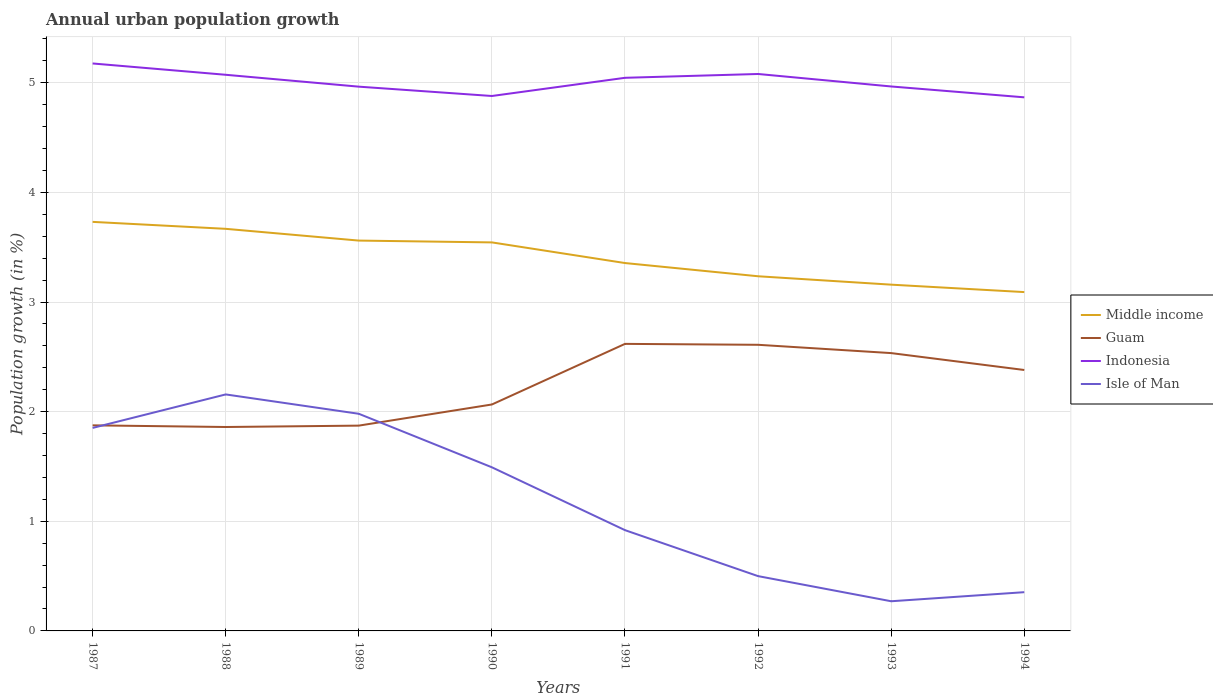Is the number of lines equal to the number of legend labels?
Your answer should be very brief. Yes. Across all years, what is the maximum percentage of urban population growth in Indonesia?
Offer a terse response. 4.87. What is the total percentage of urban population growth in Middle income in the graph?
Make the answer very short. 0.5. What is the difference between the highest and the second highest percentage of urban population growth in Middle income?
Keep it short and to the point. 0.64. What is the difference between the highest and the lowest percentage of urban population growth in Middle income?
Give a very brief answer. 4. Is the percentage of urban population growth in Indonesia strictly greater than the percentage of urban population growth in Isle of Man over the years?
Your answer should be compact. No. How many lines are there?
Provide a succinct answer. 4. What is the difference between two consecutive major ticks on the Y-axis?
Provide a short and direct response. 1. Are the values on the major ticks of Y-axis written in scientific E-notation?
Give a very brief answer. No. Does the graph contain any zero values?
Offer a terse response. No. Where does the legend appear in the graph?
Offer a terse response. Center right. What is the title of the graph?
Make the answer very short. Annual urban population growth. What is the label or title of the X-axis?
Your answer should be compact. Years. What is the label or title of the Y-axis?
Your answer should be very brief. Population growth (in %). What is the Population growth (in %) in Middle income in 1987?
Offer a terse response. 3.73. What is the Population growth (in %) of Guam in 1987?
Provide a short and direct response. 1.88. What is the Population growth (in %) in Indonesia in 1987?
Make the answer very short. 5.18. What is the Population growth (in %) in Isle of Man in 1987?
Your answer should be very brief. 1.85. What is the Population growth (in %) in Middle income in 1988?
Ensure brevity in your answer.  3.67. What is the Population growth (in %) in Guam in 1988?
Your answer should be very brief. 1.86. What is the Population growth (in %) in Indonesia in 1988?
Provide a short and direct response. 5.07. What is the Population growth (in %) of Isle of Man in 1988?
Give a very brief answer. 2.16. What is the Population growth (in %) in Middle income in 1989?
Give a very brief answer. 3.56. What is the Population growth (in %) of Guam in 1989?
Give a very brief answer. 1.87. What is the Population growth (in %) in Indonesia in 1989?
Make the answer very short. 4.96. What is the Population growth (in %) of Isle of Man in 1989?
Offer a terse response. 1.98. What is the Population growth (in %) of Middle income in 1990?
Keep it short and to the point. 3.54. What is the Population growth (in %) of Guam in 1990?
Offer a terse response. 2.07. What is the Population growth (in %) of Indonesia in 1990?
Make the answer very short. 4.88. What is the Population growth (in %) of Isle of Man in 1990?
Make the answer very short. 1.49. What is the Population growth (in %) in Middle income in 1991?
Make the answer very short. 3.36. What is the Population growth (in %) in Guam in 1991?
Your response must be concise. 2.62. What is the Population growth (in %) in Indonesia in 1991?
Your response must be concise. 5.05. What is the Population growth (in %) in Isle of Man in 1991?
Your response must be concise. 0.92. What is the Population growth (in %) of Middle income in 1992?
Your answer should be very brief. 3.24. What is the Population growth (in %) of Guam in 1992?
Give a very brief answer. 2.61. What is the Population growth (in %) in Indonesia in 1992?
Offer a very short reply. 5.08. What is the Population growth (in %) in Isle of Man in 1992?
Provide a succinct answer. 0.5. What is the Population growth (in %) of Middle income in 1993?
Give a very brief answer. 3.16. What is the Population growth (in %) in Guam in 1993?
Keep it short and to the point. 2.53. What is the Population growth (in %) of Indonesia in 1993?
Make the answer very short. 4.97. What is the Population growth (in %) of Isle of Man in 1993?
Ensure brevity in your answer.  0.27. What is the Population growth (in %) of Middle income in 1994?
Your answer should be compact. 3.09. What is the Population growth (in %) in Guam in 1994?
Your answer should be very brief. 2.38. What is the Population growth (in %) in Indonesia in 1994?
Ensure brevity in your answer.  4.87. What is the Population growth (in %) of Isle of Man in 1994?
Give a very brief answer. 0.35. Across all years, what is the maximum Population growth (in %) in Middle income?
Provide a succinct answer. 3.73. Across all years, what is the maximum Population growth (in %) of Guam?
Offer a very short reply. 2.62. Across all years, what is the maximum Population growth (in %) of Indonesia?
Offer a very short reply. 5.18. Across all years, what is the maximum Population growth (in %) in Isle of Man?
Offer a terse response. 2.16. Across all years, what is the minimum Population growth (in %) of Middle income?
Your response must be concise. 3.09. Across all years, what is the minimum Population growth (in %) of Guam?
Ensure brevity in your answer.  1.86. Across all years, what is the minimum Population growth (in %) of Indonesia?
Make the answer very short. 4.87. Across all years, what is the minimum Population growth (in %) of Isle of Man?
Make the answer very short. 0.27. What is the total Population growth (in %) in Middle income in the graph?
Give a very brief answer. 27.34. What is the total Population growth (in %) in Guam in the graph?
Ensure brevity in your answer.  17.82. What is the total Population growth (in %) in Indonesia in the graph?
Provide a succinct answer. 40.05. What is the total Population growth (in %) in Isle of Man in the graph?
Keep it short and to the point. 9.53. What is the difference between the Population growth (in %) in Middle income in 1987 and that in 1988?
Provide a short and direct response. 0.06. What is the difference between the Population growth (in %) in Guam in 1987 and that in 1988?
Offer a very short reply. 0.02. What is the difference between the Population growth (in %) of Indonesia in 1987 and that in 1988?
Keep it short and to the point. 0.1. What is the difference between the Population growth (in %) of Isle of Man in 1987 and that in 1988?
Your answer should be compact. -0.31. What is the difference between the Population growth (in %) of Middle income in 1987 and that in 1989?
Your answer should be compact. 0.17. What is the difference between the Population growth (in %) in Guam in 1987 and that in 1989?
Provide a short and direct response. 0. What is the difference between the Population growth (in %) of Indonesia in 1987 and that in 1989?
Your answer should be compact. 0.21. What is the difference between the Population growth (in %) in Isle of Man in 1987 and that in 1989?
Your answer should be compact. -0.13. What is the difference between the Population growth (in %) of Middle income in 1987 and that in 1990?
Ensure brevity in your answer.  0.19. What is the difference between the Population growth (in %) in Guam in 1987 and that in 1990?
Your answer should be very brief. -0.19. What is the difference between the Population growth (in %) in Indonesia in 1987 and that in 1990?
Make the answer very short. 0.3. What is the difference between the Population growth (in %) in Isle of Man in 1987 and that in 1990?
Offer a terse response. 0.36. What is the difference between the Population growth (in %) of Middle income in 1987 and that in 1991?
Your response must be concise. 0.38. What is the difference between the Population growth (in %) in Guam in 1987 and that in 1991?
Give a very brief answer. -0.74. What is the difference between the Population growth (in %) in Indonesia in 1987 and that in 1991?
Your response must be concise. 0.13. What is the difference between the Population growth (in %) in Isle of Man in 1987 and that in 1991?
Your response must be concise. 0.93. What is the difference between the Population growth (in %) of Middle income in 1987 and that in 1992?
Offer a very short reply. 0.5. What is the difference between the Population growth (in %) of Guam in 1987 and that in 1992?
Keep it short and to the point. -0.73. What is the difference between the Population growth (in %) in Indonesia in 1987 and that in 1992?
Give a very brief answer. 0.1. What is the difference between the Population growth (in %) of Isle of Man in 1987 and that in 1992?
Offer a very short reply. 1.35. What is the difference between the Population growth (in %) in Middle income in 1987 and that in 1993?
Offer a very short reply. 0.57. What is the difference between the Population growth (in %) in Guam in 1987 and that in 1993?
Provide a succinct answer. -0.66. What is the difference between the Population growth (in %) in Indonesia in 1987 and that in 1993?
Your answer should be compact. 0.21. What is the difference between the Population growth (in %) of Isle of Man in 1987 and that in 1993?
Make the answer very short. 1.58. What is the difference between the Population growth (in %) of Middle income in 1987 and that in 1994?
Offer a terse response. 0.64. What is the difference between the Population growth (in %) in Guam in 1987 and that in 1994?
Your answer should be very brief. -0.5. What is the difference between the Population growth (in %) of Indonesia in 1987 and that in 1994?
Offer a very short reply. 0.31. What is the difference between the Population growth (in %) of Isle of Man in 1987 and that in 1994?
Ensure brevity in your answer.  1.5. What is the difference between the Population growth (in %) of Middle income in 1988 and that in 1989?
Keep it short and to the point. 0.11. What is the difference between the Population growth (in %) of Guam in 1988 and that in 1989?
Make the answer very short. -0.01. What is the difference between the Population growth (in %) of Indonesia in 1988 and that in 1989?
Your answer should be compact. 0.11. What is the difference between the Population growth (in %) in Isle of Man in 1988 and that in 1989?
Offer a very short reply. 0.18. What is the difference between the Population growth (in %) of Middle income in 1988 and that in 1990?
Provide a short and direct response. 0.12. What is the difference between the Population growth (in %) in Guam in 1988 and that in 1990?
Give a very brief answer. -0.21. What is the difference between the Population growth (in %) in Indonesia in 1988 and that in 1990?
Offer a terse response. 0.19. What is the difference between the Population growth (in %) in Isle of Man in 1988 and that in 1990?
Make the answer very short. 0.66. What is the difference between the Population growth (in %) of Middle income in 1988 and that in 1991?
Your response must be concise. 0.31. What is the difference between the Population growth (in %) in Guam in 1988 and that in 1991?
Your response must be concise. -0.76. What is the difference between the Population growth (in %) in Indonesia in 1988 and that in 1991?
Give a very brief answer. 0.03. What is the difference between the Population growth (in %) in Isle of Man in 1988 and that in 1991?
Give a very brief answer. 1.24. What is the difference between the Population growth (in %) of Middle income in 1988 and that in 1992?
Your response must be concise. 0.43. What is the difference between the Population growth (in %) in Guam in 1988 and that in 1992?
Keep it short and to the point. -0.75. What is the difference between the Population growth (in %) in Indonesia in 1988 and that in 1992?
Provide a succinct answer. -0.01. What is the difference between the Population growth (in %) in Isle of Man in 1988 and that in 1992?
Make the answer very short. 1.66. What is the difference between the Population growth (in %) in Middle income in 1988 and that in 1993?
Offer a very short reply. 0.51. What is the difference between the Population growth (in %) in Guam in 1988 and that in 1993?
Offer a terse response. -0.67. What is the difference between the Population growth (in %) in Indonesia in 1988 and that in 1993?
Your answer should be very brief. 0.11. What is the difference between the Population growth (in %) of Isle of Man in 1988 and that in 1993?
Offer a terse response. 1.89. What is the difference between the Population growth (in %) of Middle income in 1988 and that in 1994?
Ensure brevity in your answer.  0.58. What is the difference between the Population growth (in %) of Guam in 1988 and that in 1994?
Provide a succinct answer. -0.52. What is the difference between the Population growth (in %) in Indonesia in 1988 and that in 1994?
Your answer should be very brief. 0.21. What is the difference between the Population growth (in %) of Isle of Man in 1988 and that in 1994?
Provide a short and direct response. 1.8. What is the difference between the Population growth (in %) of Middle income in 1989 and that in 1990?
Your response must be concise. 0.02. What is the difference between the Population growth (in %) in Guam in 1989 and that in 1990?
Ensure brevity in your answer.  -0.19. What is the difference between the Population growth (in %) of Indonesia in 1989 and that in 1990?
Offer a very short reply. 0.09. What is the difference between the Population growth (in %) of Isle of Man in 1989 and that in 1990?
Provide a succinct answer. 0.49. What is the difference between the Population growth (in %) in Middle income in 1989 and that in 1991?
Your answer should be compact. 0.2. What is the difference between the Population growth (in %) in Guam in 1989 and that in 1991?
Provide a short and direct response. -0.75. What is the difference between the Population growth (in %) in Indonesia in 1989 and that in 1991?
Your answer should be very brief. -0.08. What is the difference between the Population growth (in %) in Isle of Man in 1989 and that in 1991?
Your answer should be very brief. 1.06. What is the difference between the Population growth (in %) in Middle income in 1989 and that in 1992?
Your answer should be very brief. 0.33. What is the difference between the Population growth (in %) of Guam in 1989 and that in 1992?
Make the answer very short. -0.74. What is the difference between the Population growth (in %) in Indonesia in 1989 and that in 1992?
Keep it short and to the point. -0.12. What is the difference between the Population growth (in %) in Isle of Man in 1989 and that in 1992?
Ensure brevity in your answer.  1.48. What is the difference between the Population growth (in %) of Middle income in 1989 and that in 1993?
Offer a terse response. 0.4. What is the difference between the Population growth (in %) in Guam in 1989 and that in 1993?
Offer a very short reply. -0.66. What is the difference between the Population growth (in %) of Indonesia in 1989 and that in 1993?
Provide a succinct answer. -0. What is the difference between the Population growth (in %) of Isle of Man in 1989 and that in 1993?
Give a very brief answer. 1.71. What is the difference between the Population growth (in %) of Middle income in 1989 and that in 1994?
Your response must be concise. 0.47. What is the difference between the Population growth (in %) in Guam in 1989 and that in 1994?
Your answer should be compact. -0.51. What is the difference between the Population growth (in %) in Indonesia in 1989 and that in 1994?
Offer a very short reply. 0.1. What is the difference between the Population growth (in %) in Isle of Man in 1989 and that in 1994?
Ensure brevity in your answer.  1.63. What is the difference between the Population growth (in %) of Middle income in 1990 and that in 1991?
Keep it short and to the point. 0.19. What is the difference between the Population growth (in %) in Guam in 1990 and that in 1991?
Provide a succinct answer. -0.55. What is the difference between the Population growth (in %) in Indonesia in 1990 and that in 1991?
Provide a succinct answer. -0.17. What is the difference between the Population growth (in %) in Isle of Man in 1990 and that in 1991?
Your answer should be very brief. 0.57. What is the difference between the Population growth (in %) of Middle income in 1990 and that in 1992?
Give a very brief answer. 0.31. What is the difference between the Population growth (in %) in Guam in 1990 and that in 1992?
Provide a short and direct response. -0.54. What is the difference between the Population growth (in %) of Indonesia in 1990 and that in 1992?
Provide a succinct answer. -0.2. What is the difference between the Population growth (in %) of Middle income in 1990 and that in 1993?
Offer a very short reply. 0.39. What is the difference between the Population growth (in %) in Guam in 1990 and that in 1993?
Ensure brevity in your answer.  -0.47. What is the difference between the Population growth (in %) of Indonesia in 1990 and that in 1993?
Offer a terse response. -0.09. What is the difference between the Population growth (in %) of Isle of Man in 1990 and that in 1993?
Your answer should be compact. 1.22. What is the difference between the Population growth (in %) of Middle income in 1990 and that in 1994?
Offer a terse response. 0.45. What is the difference between the Population growth (in %) in Guam in 1990 and that in 1994?
Make the answer very short. -0.31. What is the difference between the Population growth (in %) of Indonesia in 1990 and that in 1994?
Your response must be concise. 0.01. What is the difference between the Population growth (in %) of Isle of Man in 1990 and that in 1994?
Offer a very short reply. 1.14. What is the difference between the Population growth (in %) of Middle income in 1991 and that in 1992?
Offer a terse response. 0.12. What is the difference between the Population growth (in %) of Guam in 1991 and that in 1992?
Keep it short and to the point. 0.01. What is the difference between the Population growth (in %) of Indonesia in 1991 and that in 1992?
Keep it short and to the point. -0.03. What is the difference between the Population growth (in %) in Isle of Man in 1991 and that in 1992?
Ensure brevity in your answer.  0.42. What is the difference between the Population growth (in %) of Middle income in 1991 and that in 1993?
Your response must be concise. 0.2. What is the difference between the Population growth (in %) in Guam in 1991 and that in 1993?
Your answer should be compact. 0.08. What is the difference between the Population growth (in %) of Indonesia in 1991 and that in 1993?
Offer a very short reply. 0.08. What is the difference between the Population growth (in %) in Isle of Man in 1991 and that in 1993?
Provide a succinct answer. 0.65. What is the difference between the Population growth (in %) of Middle income in 1991 and that in 1994?
Make the answer very short. 0.26. What is the difference between the Population growth (in %) of Guam in 1991 and that in 1994?
Offer a very short reply. 0.24. What is the difference between the Population growth (in %) in Indonesia in 1991 and that in 1994?
Your answer should be very brief. 0.18. What is the difference between the Population growth (in %) of Isle of Man in 1991 and that in 1994?
Your response must be concise. 0.57. What is the difference between the Population growth (in %) of Middle income in 1992 and that in 1993?
Your answer should be compact. 0.08. What is the difference between the Population growth (in %) of Guam in 1992 and that in 1993?
Make the answer very short. 0.08. What is the difference between the Population growth (in %) of Indonesia in 1992 and that in 1993?
Provide a succinct answer. 0.11. What is the difference between the Population growth (in %) in Isle of Man in 1992 and that in 1993?
Your response must be concise. 0.23. What is the difference between the Population growth (in %) in Middle income in 1992 and that in 1994?
Give a very brief answer. 0.14. What is the difference between the Population growth (in %) in Guam in 1992 and that in 1994?
Your answer should be compact. 0.23. What is the difference between the Population growth (in %) in Indonesia in 1992 and that in 1994?
Ensure brevity in your answer.  0.21. What is the difference between the Population growth (in %) in Isle of Man in 1992 and that in 1994?
Your response must be concise. 0.15. What is the difference between the Population growth (in %) in Middle income in 1993 and that in 1994?
Ensure brevity in your answer.  0.07. What is the difference between the Population growth (in %) in Guam in 1993 and that in 1994?
Keep it short and to the point. 0.15. What is the difference between the Population growth (in %) in Indonesia in 1993 and that in 1994?
Your answer should be compact. 0.1. What is the difference between the Population growth (in %) in Isle of Man in 1993 and that in 1994?
Offer a terse response. -0.08. What is the difference between the Population growth (in %) in Middle income in 1987 and the Population growth (in %) in Guam in 1988?
Offer a terse response. 1.87. What is the difference between the Population growth (in %) of Middle income in 1987 and the Population growth (in %) of Indonesia in 1988?
Keep it short and to the point. -1.34. What is the difference between the Population growth (in %) of Middle income in 1987 and the Population growth (in %) of Isle of Man in 1988?
Give a very brief answer. 1.57. What is the difference between the Population growth (in %) in Guam in 1987 and the Population growth (in %) in Indonesia in 1988?
Give a very brief answer. -3.2. What is the difference between the Population growth (in %) in Guam in 1987 and the Population growth (in %) in Isle of Man in 1988?
Give a very brief answer. -0.28. What is the difference between the Population growth (in %) of Indonesia in 1987 and the Population growth (in %) of Isle of Man in 1988?
Your answer should be very brief. 3.02. What is the difference between the Population growth (in %) in Middle income in 1987 and the Population growth (in %) in Guam in 1989?
Ensure brevity in your answer.  1.86. What is the difference between the Population growth (in %) in Middle income in 1987 and the Population growth (in %) in Indonesia in 1989?
Give a very brief answer. -1.23. What is the difference between the Population growth (in %) in Middle income in 1987 and the Population growth (in %) in Isle of Man in 1989?
Offer a very short reply. 1.75. What is the difference between the Population growth (in %) of Guam in 1987 and the Population growth (in %) of Indonesia in 1989?
Ensure brevity in your answer.  -3.09. What is the difference between the Population growth (in %) in Guam in 1987 and the Population growth (in %) in Isle of Man in 1989?
Keep it short and to the point. -0.11. What is the difference between the Population growth (in %) in Indonesia in 1987 and the Population growth (in %) in Isle of Man in 1989?
Provide a short and direct response. 3.2. What is the difference between the Population growth (in %) of Middle income in 1987 and the Population growth (in %) of Guam in 1990?
Keep it short and to the point. 1.67. What is the difference between the Population growth (in %) in Middle income in 1987 and the Population growth (in %) in Indonesia in 1990?
Your answer should be very brief. -1.15. What is the difference between the Population growth (in %) in Middle income in 1987 and the Population growth (in %) in Isle of Man in 1990?
Give a very brief answer. 2.24. What is the difference between the Population growth (in %) in Guam in 1987 and the Population growth (in %) in Indonesia in 1990?
Ensure brevity in your answer.  -3. What is the difference between the Population growth (in %) in Guam in 1987 and the Population growth (in %) in Isle of Man in 1990?
Your answer should be very brief. 0.38. What is the difference between the Population growth (in %) in Indonesia in 1987 and the Population growth (in %) in Isle of Man in 1990?
Your answer should be very brief. 3.68. What is the difference between the Population growth (in %) in Middle income in 1987 and the Population growth (in %) in Guam in 1991?
Your answer should be compact. 1.11. What is the difference between the Population growth (in %) of Middle income in 1987 and the Population growth (in %) of Indonesia in 1991?
Give a very brief answer. -1.31. What is the difference between the Population growth (in %) in Middle income in 1987 and the Population growth (in %) in Isle of Man in 1991?
Your answer should be compact. 2.81. What is the difference between the Population growth (in %) in Guam in 1987 and the Population growth (in %) in Indonesia in 1991?
Give a very brief answer. -3.17. What is the difference between the Population growth (in %) of Guam in 1987 and the Population growth (in %) of Isle of Man in 1991?
Provide a short and direct response. 0.96. What is the difference between the Population growth (in %) of Indonesia in 1987 and the Population growth (in %) of Isle of Man in 1991?
Keep it short and to the point. 4.26. What is the difference between the Population growth (in %) of Middle income in 1987 and the Population growth (in %) of Guam in 1992?
Make the answer very short. 1.12. What is the difference between the Population growth (in %) in Middle income in 1987 and the Population growth (in %) in Indonesia in 1992?
Keep it short and to the point. -1.35. What is the difference between the Population growth (in %) in Middle income in 1987 and the Population growth (in %) in Isle of Man in 1992?
Offer a terse response. 3.23. What is the difference between the Population growth (in %) in Guam in 1987 and the Population growth (in %) in Indonesia in 1992?
Ensure brevity in your answer.  -3.21. What is the difference between the Population growth (in %) in Guam in 1987 and the Population growth (in %) in Isle of Man in 1992?
Keep it short and to the point. 1.38. What is the difference between the Population growth (in %) in Indonesia in 1987 and the Population growth (in %) in Isle of Man in 1992?
Your response must be concise. 4.68. What is the difference between the Population growth (in %) of Middle income in 1987 and the Population growth (in %) of Guam in 1993?
Your answer should be compact. 1.2. What is the difference between the Population growth (in %) in Middle income in 1987 and the Population growth (in %) in Indonesia in 1993?
Offer a terse response. -1.24. What is the difference between the Population growth (in %) of Middle income in 1987 and the Population growth (in %) of Isle of Man in 1993?
Your answer should be very brief. 3.46. What is the difference between the Population growth (in %) in Guam in 1987 and the Population growth (in %) in Indonesia in 1993?
Offer a very short reply. -3.09. What is the difference between the Population growth (in %) in Guam in 1987 and the Population growth (in %) in Isle of Man in 1993?
Your answer should be very brief. 1.6. What is the difference between the Population growth (in %) in Indonesia in 1987 and the Population growth (in %) in Isle of Man in 1993?
Make the answer very short. 4.91. What is the difference between the Population growth (in %) in Middle income in 1987 and the Population growth (in %) in Guam in 1994?
Provide a succinct answer. 1.35. What is the difference between the Population growth (in %) in Middle income in 1987 and the Population growth (in %) in Indonesia in 1994?
Provide a succinct answer. -1.14. What is the difference between the Population growth (in %) in Middle income in 1987 and the Population growth (in %) in Isle of Man in 1994?
Ensure brevity in your answer.  3.38. What is the difference between the Population growth (in %) in Guam in 1987 and the Population growth (in %) in Indonesia in 1994?
Offer a very short reply. -2.99. What is the difference between the Population growth (in %) in Guam in 1987 and the Population growth (in %) in Isle of Man in 1994?
Your response must be concise. 1.52. What is the difference between the Population growth (in %) in Indonesia in 1987 and the Population growth (in %) in Isle of Man in 1994?
Your response must be concise. 4.82. What is the difference between the Population growth (in %) in Middle income in 1988 and the Population growth (in %) in Guam in 1989?
Provide a short and direct response. 1.8. What is the difference between the Population growth (in %) in Middle income in 1988 and the Population growth (in %) in Indonesia in 1989?
Offer a terse response. -1.3. What is the difference between the Population growth (in %) in Middle income in 1988 and the Population growth (in %) in Isle of Man in 1989?
Keep it short and to the point. 1.69. What is the difference between the Population growth (in %) in Guam in 1988 and the Population growth (in %) in Indonesia in 1989?
Provide a short and direct response. -3.1. What is the difference between the Population growth (in %) of Guam in 1988 and the Population growth (in %) of Isle of Man in 1989?
Provide a succinct answer. -0.12. What is the difference between the Population growth (in %) of Indonesia in 1988 and the Population growth (in %) of Isle of Man in 1989?
Provide a succinct answer. 3.09. What is the difference between the Population growth (in %) in Middle income in 1988 and the Population growth (in %) in Guam in 1990?
Keep it short and to the point. 1.6. What is the difference between the Population growth (in %) of Middle income in 1988 and the Population growth (in %) of Indonesia in 1990?
Keep it short and to the point. -1.21. What is the difference between the Population growth (in %) of Middle income in 1988 and the Population growth (in %) of Isle of Man in 1990?
Keep it short and to the point. 2.18. What is the difference between the Population growth (in %) of Guam in 1988 and the Population growth (in %) of Indonesia in 1990?
Provide a short and direct response. -3.02. What is the difference between the Population growth (in %) in Guam in 1988 and the Population growth (in %) in Isle of Man in 1990?
Your response must be concise. 0.37. What is the difference between the Population growth (in %) of Indonesia in 1988 and the Population growth (in %) of Isle of Man in 1990?
Make the answer very short. 3.58. What is the difference between the Population growth (in %) of Middle income in 1988 and the Population growth (in %) of Guam in 1991?
Keep it short and to the point. 1.05. What is the difference between the Population growth (in %) of Middle income in 1988 and the Population growth (in %) of Indonesia in 1991?
Ensure brevity in your answer.  -1.38. What is the difference between the Population growth (in %) of Middle income in 1988 and the Population growth (in %) of Isle of Man in 1991?
Make the answer very short. 2.75. What is the difference between the Population growth (in %) of Guam in 1988 and the Population growth (in %) of Indonesia in 1991?
Your answer should be compact. -3.19. What is the difference between the Population growth (in %) of Guam in 1988 and the Population growth (in %) of Isle of Man in 1991?
Give a very brief answer. 0.94. What is the difference between the Population growth (in %) in Indonesia in 1988 and the Population growth (in %) in Isle of Man in 1991?
Your response must be concise. 4.15. What is the difference between the Population growth (in %) in Middle income in 1988 and the Population growth (in %) in Guam in 1992?
Keep it short and to the point. 1.06. What is the difference between the Population growth (in %) in Middle income in 1988 and the Population growth (in %) in Indonesia in 1992?
Your answer should be compact. -1.41. What is the difference between the Population growth (in %) in Middle income in 1988 and the Population growth (in %) in Isle of Man in 1992?
Give a very brief answer. 3.17. What is the difference between the Population growth (in %) of Guam in 1988 and the Population growth (in %) of Indonesia in 1992?
Your answer should be very brief. -3.22. What is the difference between the Population growth (in %) in Guam in 1988 and the Population growth (in %) in Isle of Man in 1992?
Keep it short and to the point. 1.36. What is the difference between the Population growth (in %) of Indonesia in 1988 and the Population growth (in %) of Isle of Man in 1992?
Your answer should be very brief. 4.57. What is the difference between the Population growth (in %) in Middle income in 1988 and the Population growth (in %) in Guam in 1993?
Offer a terse response. 1.13. What is the difference between the Population growth (in %) in Middle income in 1988 and the Population growth (in %) in Indonesia in 1993?
Your answer should be very brief. -1.3. What is the difference between the Population growth (in %) in Middle income in 1988 and the Population growth (in %) in Isle of Man in 1993?
Your answer should be compact. 3.4. What is the difference between the Population growth (in %) of Guam in 1988 and the Population growth (in %) of Indonesia in 1993?
Your answer should be very brief. -3.11. What is the difference between the Population growth (in %) in Guam in 1988 and the Population growth (in %) in Isle of Man in 1993?
Offer a very short reply. 1.59. What is the difference between the Population growth (in %) in Indonesia in 1988 and the Population growth (in %) in Isle of Man in 1993?
Your answer should be compact. 4.8. What is the difference between the Population growth (in %) in Middle income in 1988 and the Population growth (in %) in Guam in 1994?
Your answer should be compact. 1.29. What is the difference between the Population growth (in %) in Middle income in 1988 and the Population growth (in %) in Indonesia in 1994?
Keep it short and to the point. -1.2. What is the difference between the Population growth (in %) in Middle income in 1988 and the Population growth (in %) in Isle of Man in 1994?
Your response must be concise. 3.31. What is the difference between the Population growth (in %) in Guam in 1988 and the Population growth (in %) in Indonesia in 1994?
Provide a short and direct response. -3.01. What is the difference between the Population growth (in %) in Guam in 1988 and the Population growth (in %) in Isle of Man in 1994?
Your answer should be very brief. 1.51. What is the difference between the Population growth (in %) in Indonesia in 1988 and the Population growth (in %) in Isle of Man in 1994?
Ensure brevity in your answer.  4.72. What is the difference between the Population growth (in %) in Middle income in 1989 and the Population growth (in %) in Guam in 1990?
Keep it short and to the point. 1.5. What is the difference between the Population growth (in %) in Middle income in 1989 and the Population growth (in %) in Indonesia in 1990?
Keep it short and to the point. -1.32. What is the difference between the Population growth (in %) in Middle income in 1989 and the Population growth (in %) in Isle of Man in 1990?
Your answer should be compact. 2.07. What is the difference between the Population growth (in %) of Guam in 1989 and the Population growth (in %) of Indonesia in 1990?
Give a very brief answer. -3.01. What is the difference between the Population growth (in %) in Guam in 1989 and the Population growth (in %) in Isle of Man in 1990?
Your response must be concise. 0.38. What is the difference between the Population growth (in %) in Indonesia in 1989 and the Population growth (in %) in Isle of Man in 1990?
Give a very brief answer. 3.47. What is the difference between the Population growth (in %) of Middle income in 1989 and the Population growth (in %) of Guam in 1991?
Offer a terse response. 0.94. What is the difference between the Population growth (in %) in Middle income in 1989 and the Population growth (in %) in Indonesia in 1991?
Your answer should be compact. -1.48. What is the difference between the Population growth (in %) in Middle income in 1989 and the Population growth (in %) in Isle of Man in 1991?
Ensure brevity in your answer.  2.64. What is the difference between the Population growth (in %) of Guam in 1989 and the Population growth (in %) of Indonesia in 1991?
Your response must be concise. -3.17. What is the difference between the Population growth (in %) in Guam in 1989 and the Population growth (in %) in Isle of Man in 1991?
Provide a succinct answer. 0.95. What is the difference between the Population growth (in %) in Indonesia in 1989 and the Population growth (in %) in Isle of Man in 1991?
Provide a succinct answer. 4.05. What is the difference between the Population growth (in %) of Middle income in 1989 and the Population growth (in %) of Guam in 1992?
Provide a succinct answer. 0.95. What is the difference between the Population growth (in %) in Middle income in 1989 and the Population growth (in %) in Indonesia in 1992?
Your response must be concise. -1.52. What is the difference between the Population growth (in %) in Middle income in 1989 and the Population growth (in %) in Isle of Man in 1992?
Make the answer very short. 3.06. What is the difference between the Population growth (in %) of Guam in 1989 and the Population growth (in %) of Indonesia in 1992?
Keep it short and to the point. -3.21. What is the difference between the Population growth (in %) in Guam in 1989 and the Population growth (in %) in Isle of Man in 1992?
Give a very brief answer. 1.37. What is the difference between the Population growth (in %) of Indonesia in 1989 and the Population growth (in %) of Isle of Man in 1992?
Provide a short and direct response. 4.46. What is the difference between the Population growth (in %) in Middle income in 1989 and the Population growth (in %) in Guam in 1993?
Your answer should be compact. 1.03. What is the difference between the Population growth (in %) in Middle income in 1989 and the Population growth (in %) in Indonesia in 1993?
Provide a succinct answer. -1.41. What is the difference between the Population growth (in %) in Middle income in 1989 and the Population growth (in %) in Isle of Man in 1993?
Make the answer very short. 3.29. What is the difference between the Population growth (in %) of Guam in 1989 and the Population growth (in %) of Indonesia in 1993?
Offer a terse response. -3.09. What is the difference between the Population growth (in %) in Guam in 1989 and the Population growth (in %) in Isle of Man in 1993?
Give a very brief answer. 1.6. What is the difference between the Population growth (in %) in Indonesia in 1989 and the Population growth (in %) in Isle of Man in 1993?
Your response must be concise. 4.69. What is the difference between the Population growth (in %) in Middle income in 1989 and the Population growth (in %) in Guam in 1994?
Provide a succinct answer. 1.18. What is the difference between the Population growth (in %) of Middle income in 1989 and the Population growth (in %) of Indonesia in 1994?
Make the answer very short. -1.31. What is the difference between the Population growth (in %) of Middle income in 1989 and the Population growth (in %) of Isle of Man in 1994?
Give a very brief answer. 3.21. What is the difference between the Population growth (in %) in Guam in 1989 and the Population growth (in %) in Indonesia in 1994?
Provide a succinct answer. -2.99. What is the difference between the Population growth (in %) in Guam in 1989 and the Population growth (in %) in Isle of Man in 1994?
Ensure brevity in your answer.  1.52. What is the difference between the Population growth (in %) in Indonesia in 1989 and the Population growth (in %) in Isle of Man in 1994?
Offer a very short reply. 4.61. What is the difference between the Population growth (in %) in Middle income in 1990 and the Population growth (in %) in Guam in 1991?
Keep it short and to the point. 0.93. What is the difference between the Population growth (in %) of Middle income in 1990 and the Population growth (in %) of Indonesia in 1991?
Offer a very short reply. -1.5. What is the difference between the Population growth (in %) of Middle income in 1990 and the Population growth (in %) of Isle of Man in 1991?
Ensure brevity in your answer.  2.62. What is the difference between the Population growth (in %) in Guam in 1990 and the Population growth (in %) in Indonesia in 1991?
Provide a short and direct response. -2.98. What is the difference between the Population growth (in %) in Guam in 1990 and the Population growth (in %) in Isle of Man in 1991?
Offer a terse response. 1.15. What is the difference between the Population growth (in %) in Indonesia in 1990 and the Population growth (in %) in Isle of Man in 1991?
Ensure brevity in your answer.  3.96. What is the difference between the Population growth (in %) of Middle income in 1990 and the Population growth (in %) of Guam in 1992?
Give a very brief answer. 0.93. What is the difference between the Population growth (in %) in Middle income in 1990 and the Population growth (in %) in Indonesia in 1992?
Your answer should be very brief. -1.54. What is the difference between the Population growth (in %) in Middle income in 1990 and the Population growth (in %) in Isle of Man in 1992?
Your response must be concise. 3.04. What is the difference between the Population growth (in %) in Guam in 1990 and the Population growth (in %) in Indonesia in 1992?
Make the answer very short. -3.01. What is the difference between the Population growth (in %) of Guam in 1990 and the Population growth (in %) of Isle of Man in 1992?
Ensure brevity in your answer.  1.57. What is the difference between the Population growth (in %) of Indonesia in 1990 and the Population growth (in %) of Isle of Man in 1992?
Provide a succinct answer. 4.38. What is the difference between the Population growth (in %) in Middle income in 1990 and the Population growth (in %) in Guam in 1993?
Your answer should be very brief. 1.01. What is the difference between the Population growth (in %) of Middle income in 1990 and the Population growth (in %) of Indonesia in 1993?
Offer a terse response. -1.42. What is the difference between the Population growth (in %) of Middle income in 1990 and the Population growth (in %) of Isle of Man in 1993?
Keep it short and to the point. 3.27. What is the difference between the Population growth (in %) of Guam in 1990 and the Population growth (in %) of Indonesia in 1993?
Your answer should be compact. -2.9. What is the difference between the Population growth (in %) of Guam in 1990 and the Population growth (in %) of Isle of Man in 1993?
Offer a terse response. 1.79. What is the difference between the Population growth (in %) of Indonesia in 1990 and the Population growth (in %) of Isle of Man in 1993?
Make the answer very short. 4.61. What is the difference between the Population growth (in %) in Middle income in 1990 and the Population growth (in %) in Guam in 1994?
Offer a very short reply. 1.16. What is the difference between the Population growth (in %) of Middle income in 1990 and the Population growth (in %) of Indonesia in 1994?
Ensure brevity in your answer.  -1.32. What is the difference between the Population growth (in %) of Middle income in 1990 and the Population growth (in %) of Isle of Man in 1994?
Your answer should be compact. 3.19. What is the difference between the Population growth (in %) of Guam in 1990 and the Population growth (in %) of Indonesia in 1994?
Keep it short and to the point. -2.8. What is the difference between the Population growth (in %) of Guam in 1990 and the Population growth (in %) of Isle of Man in 1994?
Provide a short and direct response. 1.71. What is the difference between the Population growth (in %) in Indonesia in 1990 and the Population growth (in %) in Isle of Man in 1994?
Provide a short and direct response. 4.53. What is the difference between the Population growth (in %) of Middle income in 1991 and the Population growth (in %) of Guam in 1992?
Provide a succinct answer. 0.75. What is the difference between the Population growth (in %) of Middle income in 1991 and the Population growth (in %) of Indonesia in 1992?
Offer a terse response. -1.72. What is the difference between the Population growth (in %) of Middle income in 1991 and the Population growth (in %) of Isle of Man in 1992?
Ensure brevity in your answer.  2.86. What is the difference between the Population growth (in %) in Guam in 1991 and the Population growth (in %) in Indonesia in 1992?
Offer a very short reply. -2.46. What is the difference between the Population growth (in %) in Guam in 1991 and the Population growth (in %) in Isle of Man in 1992?
Your answer should be very brief. 2.12. What is the difference between the Population growth (in %) of Indonesia in 1991 and the Population growth (in %) of Isle of Man in 1992?
Give a very brief answer. 4.55. What is the difference between the Population growth (in %) in Middle income in 1991 and the Population growth (in %) in Guam in 1993?
Your answer should be very brief. 0.82. What is the difference between the Population growth (in %) in Middle income in 1991 and the Population growth (in %) in Indonesia in 1993?
Give a very brief answer. -1.61. What is the difference between the Population growth (in %) of Middle income in 1991 and the Population growth (in %) of Isle of Man in 1993?
Make the answer very short. 3.09. What is the difference between the Population growth (in %) of Guam in 1991 and the Population growth (in %) of Indonesia in 1993?
Keep it short and to the point. -2.35. What is the difference between the Population growth (in %) of Guam in 1991 and the Population growth (in %) of Isle of Man in 1993?
Give a very brief answer. 2.35. What is the difference between the Population growth (in %) of Indonesia in 1991 and the Population growth (in %) of Isle of Man in 1993?
Make the answer very short. 4.77. What is the difference between the Population growth (in %) of Middle income in 1991 and the Population growth (in %) of Guam in 1994?
Your response must be concise. 0.98. What is the difference between the Population growth (in %) in Middle income in 1991 and the Population growth (in %) in Indonesia in 1994?
Ensure brevity in your answer.  -1.51. What is the difference between the Population growth (in %) in Middle income in 1991 and the Population growth (in %) in Isle of Man in 1994?
Offer a terse response. 3. What is the difference between the Population growth (in %) in Guam in 1991 and the Population growth (in %) in Indonesia in 1994?
Your answer should be very brief. -2.25. What is the difference between the Population growth (in %) of Guam in 1991 and the Population growth (in %) of Isle of Man in 1994?
Your response must be concise. 2.27. What is the difference between the Population growth (in %) in Indonesia in 1991 and the Population growth (in %) in Isle of Man in 1994?
Make the answer very short. 4.69. What is the difference between the Population growth (in %) of Middle income in 1992 and the Population growth (in %) of Guam in 1993?
Offer a very short reply. 0.7. What is the difference between the Population growth (in %) of Middle income in 1992 and the Population growth (in %) of Indonesia in 1993?
Provide a succinct answer. -1.73. What is the difference between the Population growth (in %) of Middle income in 1992 and the Population growth (in %) of Isle of Man in 1993?
Your response must be concise. 2.96. What is the difference between the Population growth (in %) in Guam in 1992 and the Population growth (in %) in Indonesia in 1993?
Your response must be concise. -2.36. What is the difference between the Population growth (in %) in Guam in 1992 and the Population growth (in %) in Isle of Man in 1993?
Provide a succinct answer. 2.34. What is the difference between the Population growth (in %) in Indonesia in 1992 and the Population growth (in %) in Isle of Man in 1993?
Provide a succinct answer. 4.81. What is the difference between the Population growth (in %) of Middle income in 1992 and the Population growth (in %) of Guam in 1994?
Your answer should be compact. 0.85. What is the difference between the Population growth (in %) of Middle income in 1992 and the Population growth (in %) of Indonesia in 1994?
Give a very brief answer. -1.63. What is the difference between the Population growth (in %) of Middle income in 1992 and the Population growth (in %) of Isle of Man in 1994?
Your response must be concise. 2.88. What is the difference between the Population growth (in %) in Guam in 1992 and the Population growth (in %) in Indonesia in 1994?
Offer a terse response. -2.26. What is the difference between the Population growth (in %) of Guam in 1992 and the Population growth (in %) of Isle of Man in 1994?
Offer a very short reply. 2.26. What is the difference between the Population growth (in %) in Indonesia in 1992 and the Population growth (in %) in Isle of Man in 1994?
Keep it short and to the point. 4.73. What is the difference between the Population growth (in %) in Middle income in 1993 and the Population growth (in %) in Guam in 1994?
Offer a terse response. 0.78. What is the difference between the Population growth (in %) in Middle income in 1993 and the Population growth (in %) in Indonesia in 1994?
Make the answer very short. -1.71. What is the difference between the Population growth (in %) in Middle income in 1993 and the Population growth (in %) in Isle of Man in 1994?
Provide a short and direct response. 2.81. What is the difference between the Population growth (in %) of Guam in 1993 and the Population growth (in %) of Indonesia in 1994?
Ensure brevity in your answer.  -2.33. What is the difference between the Population growth (in %) of Guam in 1993 and the Population growth (in %) of Isle of Man in 1994?
Provide a succinct answer. 2.18. What is the difference between the Population growth (in %) of Indonesia in 1993 and the Population growth (in %) of Isle of Man in 1994?
Make the answer very short. 4.61. What is the average Population growth (in %) in Middle income per year?
Your answer should be very brief. 3.42. What is the average Population growth (in %) of Guam per year?
Your answer should be very brief. 2.23. What is the average Population growth (in %) in Indonesia per year?
Your answer should be compact. 5.01. What is the average Population growth (in %) in Isle of Man per year?
Give a very brief answer. 1.19. In the year 1987, what is the difference between the Population growth (in %) in Middle income and Population growth (in %) in Guam?
Give a very brief answer. 1.86. In the year 1987, what is the difference between the Population growth (in %) of Middle income and Population growth (in %) of Indonesia?
Offer a terse response. -1.45. In the year 1987, what is the difference between the Population growth (in %) in Middle income and Population growth (in %) in Isle of Man?
Make the answer very short. 1.88. In the year 1987, what is the difference between the Population growth (in %) in Guam and Population growth (in %) in Indonesia?
Keep it short and to the point. -3.3. In the year 1987, what is the difference between the Population growth (in %) in Guam and Population growth (in %) in Isle of Man?
Offer a very short reply. 0.02. In the year 1987, what is the difference between the Population growth (in %) of Indonesia and Population growth (in %) of Isle of Man?
Keep it short and to the point. 3.32. In the year 1988, what is the difference between the Population growth (in %) in Middle income and Population growth (in %) in Guam?
Your response must be concise. 1.81. In the year 1988, what is the difference between the Population growth (in %) of Middle income and Population growth (in %) of Indonesia?
Ensure brevity in your answer.  -1.41. In the year 1988, what is the difference between the Population growth (in %) of Middle income and Population growth (in %) of Isle of Man?
Make the answer very short. 1.51. In the year 1988, what is the difference between the Population growth (in %) in Guam and Population growth (in %) in Indonesia?
Your answer should be very brief. -3.21. In the year 1988, what is the difference between the Population growth (in %) of Guam and Population growth (in %) of Isle of Man?
Offer a very short reply. -0.3. In the year 1988, what is the difference between the Population growth (in %) of Indonesia and Population growth (in %) of Isle of Man?
Give a very brief answer. 2.92. In the year 1989, what is the difference between the Population growth (in %) of Middle income and Population growth (in %) of Guam?
Offer a very short reply. 1.69. In the year 1989, what is the difference between the Population growth (in %) in Middle income and Population growth (in %) in Indonesia?
Ensure brevity in your answer.  -1.4. In the year 1989, what is the difference between the Population growth (in %) of Middle income and Population growth (in %) of Isle of Man?
Keep it short and to the point. 1.58. In the year 1989, what is the difference between the Population growth (in %) of Guam and Population growth (in %) of Indonesia?
Give a very brief answer. -3.09. In the year 1989, what is the difference between the Population growth (in %) in Guam and Population growth (in %) in Isle of Man?
Your response must be concise. -0.11. In the year 1989, what is the difference between the Population growth (in %) in Indonesia and Population growth (in %) in Isle of Man?
Provide a short and direct response. 2.98. In the year 1990, what is the difference between the Population growth (in %) of Middle income and Population growth (in %) of Guam?
Your answer should be compact. 1.48. In the year 1990, what is the difference between the Population growth (in %) of Middle income and Population growth (in %) of Indonesia?
Your answer should be very brief. -1.34. In the year 1990, what is the difference between the Population growth (in %) in Middle income and Population growth (in %) in Isle of Man?
Make the answer very short. 2.05. In the year 1990, what is the difference between the Population growth (in %) in Guam and Population growth (in %) in Indonesia?
Offer a terse response. -2.81. In the year 1990, what is the difference between the Population growth (in %) of Guam and Population growth (in %) of Isle of Man?
Offer a very short reply. 0.57. In the year 1990, what is the difference between the Population growth (in %) in Indonesia and Population growth (in %) in Isle of Man?
Your answer should be very brief. 3.39. In the year 1991, what is the difference between the Population growth (in %) in Middle income and Population growth (in %) in Guam?
Your response must be concise. 0.74. In the year 1991, what is the difference between the Population growth (in %) of Middle income and Population growth (in %) of Indonesia?
Keep it short and to the point. -1.69. In the year 1991, what is the difference between the Population growth (in %) of Middle income and Population growth (in %) of Isle of Man?
Ensure brevity in your answer.  2.44. In the year 1991, what is the difference between the Population growth (in %) of Guam and Population growth (in %) of Indonesia?
Your response must be concise. -2.43. In the year 1991, what is the difference between the Population growth (in %) in Guam and Population growth (in %) in Isle of Man?
Keep it short and to the point. 1.7. In the year 1991, what is the difference between the Population growth (in %) of Indonesia and Population growth (in %) of Isle of Man?
Offer a very short reply. 4.13. In the year 1992, what is the difference between the Population growth (in %) of Middle income and Population growth (in %) of Guam?
Keep it short and to the point. 0.63. In the year 1992, what is the difference between the Population growth (in %) in Middle income and Population growth (in %) in Indonesia?
Offer a terse response. -1.85. In the year 1992, what is the difference between the Population growth (in %) of Middle income and Population growth (in %) of Isle of Man?
Your answer should be very brief. 2.74. In the year 1992, what is the difference between the Population growth (in %) in Guam and Population growth (in %) in Indonesia?
Ensure brevity in your answer.  -2.47. In the year 1992, what is the difference between the Population growth (in %) of Guam and Population growth (in %) of Isle of Man?
Ensure brevity in your answer.  2.11. In the year 1992, what is the difference between the Population growth (in %) in Indonesia and Population growth (in %) in Isle of Man?
Make the answer very short. 4.58. In the year 1993, what is the difference between the Population growth (in %) of Middle income and Population growth (in %) of Guam?
Your answer should be compact. 0.62. In the year 1993, what is the difference between the Population growth (in %) of Middle income and Population growth (in %) of Indonesia?
Your answer should be very brief. -1.81. In the year 1993, what is the difference between the Population growth (in %) of Middle income and Population growth (in %) of Isle of Man?
Give a very brief answer. 2.89. In the year 1993, what is the difference between the Population growth (in %) of Guam and Population growth (in %) of Indonesia?
Provide a short and direct response. -2.43. In the year 1993, what is the difference between the Population growth (in %) of Guam and Population growth (in %) of Isle of Man?
Your response must be concise. 2.26. In the year 1993, what is the difference between the Population growth (in %) in Indonesia and Population growth (in %) in Isle of Man?
Provide a short and direct response. 4.7. In the year 1994, what is the difference between the Population growth (in %) in Middle income and Population growth (in %) in Guam?
Your answer should be compact. 0.71. In the year 1994, what is the difference between the Population growth (in %) in Middle income and Population growth (in %) in Indonesia?
Your response must be concise. -1.78. In the year 1994, what is the difference between the Population growth (in %) of Middle income and Population growth (in %) of Isle of Man?
Your answer should be very brief. 2.74. In the year 1994, what is the difference between the Population growth (in %) in Guam and Population growth (in %) in Indonesia?
Provide a short and direct response. -2.49. In the year 1994, what is the difference between the Population growth (in %) of Guam and Population growth (in %) of Isle of Man?
Your response must be concise. 2.03. In the year 1994, what is the difference between the Population growth (in %) in Indonesia and Population growth (in %) in Isle of Man?
Give a very brief answer. 4.51. What is the ratio of the Population growth (in %) of Middle income in 1987 to that in 1988?
Give a very brief answer. 1.02. What is the ratio of the Population growth (in %) of Guam in 1987 to that in 1988?
Give a very brief answer. 1.01. What is the ratio of the Population growth (in %) of Indonesia in 1987 to that in 1988?
Your answer should be compact. 1.02. What is the ratio of the Population growth (in %) in Isle of Man in 1987 to that in 1988?
Keep it short and to the point. 0.86. What is the ratio of the Population growth (in %) of Middle income in 1987 to that in 1989?
Ensure brevity in your answer.  1.05. What is the ratio of the Population growth (in %) of Guam in 1987 to that in 1989?
Offer a very short reply. 1. What is the ratio of the Population growth (in %) of Indonesia in 1987 to that in 1989?
Offer a terse response. 1.04. What is the ratio of the Population growth (in %) in Isle of Man in 1987 to that in 1989?
Offer a terse response. 0.93. What is the ratio of the Population growth (in %) in Middle income in 1987 to that in 1990?
Ensure brevity in your answer.  1.05. What is the ratio of the Population growth (in %) of Guam in 1987 to that in 1990?
Give a very brief answer. 0.91. What is the ratio of the Population growth (in %) in Indonesia in 1987 to that in 1990?
Give a very brief answer. 1.06. What is the ratio of the Population growth (in %) in Isle of Man in 1987 to that in 1990?
Offer a very short reply. 1.24. What is the ratio of the Population growth (in %) in Middle income in 1987 to that in 1991?
Your answer should be very brief. 1.11. What is the ratio of the Population growth (in %) of Guam in 1987 to that in 1991?
Make the answer very short. 0.72. What is the ratio of the Population growth (in %) of Indonesia in 1987 to that in 1991?
Your response must be concise. 1.03. What is the ratio of the Population growth (in %) in Isle of Man in 1987 to that in 1991?
Ensure brevity in your answer.  2.01. What is the ratio of the Population growth (in %) of Middle income in 1987 to that in 1992?
Offer a terse response. 1.15. What is the ratio of the Population growth (in %) of Guam in 1987 to that in 1992?
Your answer should be compact. 0.72. What is the ratio of the Population growth (in %) of Indonesia in 1987 to that in 1992?
Ensure brevity in your answer.  1.02. What is the ratio of the Population growth (in %) in Isle of Man in 1987 to that in 1992?
Your answer should be very brief. 3.7. What is the ratio of the Population growth (in %) of Middle income in 1987 to that in 1993?
Give a very brief answer. 1.18. What is the ratio of the Population growth (in %) in Guam in 1987 to that in 1993?
Your answer should be very brief. 0.74. What is the ratio of the Population growth (in %) of Indonesia in 1987 to that in 1993?
Make the answer very short. 1.04. What is the ratio of the Population growth (in %) of Isle of Man in 1987 to that in 1993?
Keep it short and to the point. 6.84. What is the ratio of the Population growth (in %) in Middle income in 1987 to that in 1994?
Your response must be concise. 1.21. What is the ratio of the Population growth (in %) of Guam in 1987 to that in 1994?
Provide a succinct answer. 0.79. What is the ratio of the Population growth (in %) in Indonesia in 1987 to that in 1994?
Ensure brevity in your answer.  1.06. What is the ratio of the Population growth (in %) of Isle of Man in 1987 to that in 1994?
Offer a very short reply. 5.24. What is the ratio of the Population growth (in %) in Middle income in 1988 to that in 1989?
Ensure brevity in your answer.  1.03. What is the ratio of the Population growth (in %) in Guam in 1988 to that in 1989?
Provide a short and direct response. 0.99. What is the ratio of the Population growth (in %) in Indonesia in 1988 to that in 1989?
Provide a short and direct response. 1.02. What is the ratio of the Population growth (in %) in Isle of Man in 1988 to that in 1989?
Your answer should be very brief. 1.09. What is the ratio of the Population growth (in %) in Middle income in 1988 to that in 1990?
Provide a short and direct response. 1.03. What is the ratio of the Population growth (in %) in Guam in 1988 to that in 1990?
Offer a very short reply. 0.9. What is the ratio of the Population growth (in %) in Indonesia in 1988 to that in 1990?
Keep it short and to the point. 1.04. What is the ratio of the Population growth (in %) in Isle of Man in 1988 to that in 1990?
Provide a short and direct response. 1.45. What is the ratio of the Population growth (in %) in Middle income in 1988 to that in 1991?
Provide a short and direct response. 1.09. What is the ratio of the Population growth (in %) in Guam in 1988 to that in 1991?
Ensure brevity in your answer.  0.71. What is the ratio of the Population growth (in %) in Isle of Man in 1988 to that in 1991?
Offer a very short reply. 2.35. What is the ratio of the Population growth (in %) of Middle income in 1988 to that in 1992?
Your answer should be very brief. 1.13. What is the ratio of the Population growth (in %) of Guam in 1988 to that in 1992?
Offer a very short reply. 0.71. What is the ratio of the Population growth (in %) in Indonesia in 1988 to that in 1992?
Ensure brevity in your answer.  1. What is the ratio of the Population growth (in %) in Isle of Man in 1988 to that in 1992?
Ensure brevity in your answer.  4.32. What is the ratio of the Population growth (in %) in Middle income in 1988 to that in 1993?
Make the answer very short. 1.16. What is the ratio of the Population growth (in %) of Guam in 1988 to that in 1993?
Your answer should be very brief. 0.73. What is the ratio of the Population growth (in %) in Indonesia in 1988 to that in 1993?
Offer a terse response. 1.02. What is the ratio of the Population growth (in %) in Isle of Man in 1988 to that in 1993?
Offer a very short reply. 7.97. What is the ratio of the Population growth (in %) of Middle income in 1988 to that in 1994?
Offer a very short reply. 1.19. What is the ratio of the Population growth (in %) in Guam in 1988 to that in 1994?
Your response must be concise. 0.78. What is the ratio of the Population growth (in %) in Indonesia in 1988 to that in 1994?
Provide a short and direct response. 1.04. What is the ratio of the Population growth (in %) of Isle of Man in 1988 to that in 1994?
Provide a short and direct response. 6.1. What is the ratio of the Population growth (in %) in Middle income in 1989 to that in 1990?
Keep it short and to the point. 1. What is the ratio of the Population growth (in %) in Guam in 1989 to that in 1990?
Your response must be concise. 0.91. What is the ratio of the Population growth (in %) in Indonesia in 1989 to that in 1990?
Offer a terse response. 1.02. What is the ratio of the Population growth (in %) in Isle of Man in 1989 to that in 1990?
Your answer should be compact. 1.33. What is the ratio of the Population growth (in %) in Middle income in 1989 to that in 1991?
Keep it short and to the point. 1.06. What is the ratio of the Population growth (in %) of Guam in 1989 to that in 1991?
Your response must be concise. 0.72. What is the ratio of the Population growth (in %) of Indonesia in 1989 to that in 1991?
Offer a very short reply. 0.98. What is the ratio of the Population growth (in %) in Isle of Man in 1989 to that in 1991?
Provide a succinct answer. 2.15. What is the ratio of the Population growth (in %) of Middle income in 1989 to that in 1992?
Provide a short and direct response. 1.1. What is the ratio of the Population growth (in %) in Guam in 1989 to that in 1992?
Make the answer very short. 0.72. What is the ratio of the Population growth (in %) of Indonesia in 1989 to that in 1992?
Make the answer very short. 0.98. What is the ratio of the Population growth (in %) in Isle of Man in 1989 to that in 1992?
Your response must be concise. 3.96. What is the ratio of the Population growth (in %) in Middle income in 1989 to that in 1993?
Ensure brevity in your answer.  1.13. What is the ratio of the Population growth (in %) of Guam in 1989 to that in 1993?
Make the answer very short. 0.74. What is the ratio of the Population growth (in %) in Isle of Man in 1989 to that in 1993?
Offer a terse response. 7.32. What is the ratio of the Population growth (in %) of Middle income in 1989 to that in 1994?
Keep it short and to the point. 1.15. What is the ratio of the Population growth (in %) of Guam in 1989 to that in 1994?
Make the answer very short. 0.79. What is the ratio of the Population growth (in %) in Isle of Man in 1989 to that in 1994?
Your answer should be very brief. 5.6. What is the ratio of the Population growth (in %) of Middle income in 1990 to that in 1991?
Provide a succinct answer. 1.06. What is the ratio of the Population growth (in %) of Guam in 1990 to that in 1991?
Offer a terse response. 0.79. What is the ratio of the Population growth (in %) of Indonesia in 1990 to that in 1991?
Keep it short and to the point. 0.97. What is the ratio of the Population growth (in %) of Isle of Man in 1990 to that in 1991?
Provide a succinct answer. 1.62. What is the ratio of the Population growth (in %) in Middle income in 1990 to that in 1992?
Ensure brevity in your answer.  1.1. What is the ratio of the Population growth (in %) in Guam in 1990 to that in 1992?
Provide a short and direct response. 0.79. What is the ratio of the Population growth (in %) in Indonesia in 1990 to that in 1992?
Offer a very short reply. 0.96. What is the ratio of the Population growth (in %) of Isle of Man in 1990 to that in 1992?
Your answer should be very brief. 2.99. What is the ratio of the Population growth (in %) of Middle income in 1990 to that in 1993?
Make the answer very short. 1.12. What is the ratio of the Population growth (in %) in Guam in 1990 to that in 1993?
Your answer should be compact. 0.81. What is the ratio of the Population growth (in %) of Indonesia in 1990 to that in 1993?
Offer a terse response. 0.98. What is the ratio of the Population growth (in %) in Isle of Man in 1990 to that in 1993?
Provide a succinct answer. 5.52. What is the ratio of the Population growth (in %) of Middle income in 1990 to that in 1994?
Offer a very short reply. 1.15. What is the ratio of the Population growth (in %) of Guam in 1990 to that in 1994?
Ensure brevity in your answer.  0.87. What is the ratio of the Population growth (in %) of Indonesia in 1990 to that in 1994?
Give a very brief answer. 1. What is the ratio of the Population growth (in %) in Isle of Man in 1990 to that in 1994?
Offer a terse response. 4.22. What is the ratio of the Population growth (in %) in Middle income in 1991 to that in 1992?
Offer a terse response. 1.04. What is the ratio of the Population growth (in %) in Isle of Man in 1991 to that in 1992?
Offer a very short reply. 1.84. What is the ratio of the Population growth (in %) in Middle income in 1991 to that in 1993?
Keep it short and to the point. 1.06. What is the ratio of the Population growth (in %) of Guam in 1991 to that in 1993?
Make the answer very short. 1.03. What is the ratio of the Population growth (in %) in Indonesia in 1991 to that in 1993?
Your response must be concise. 1.02. What is the ratio of the Population growth (in %) of Isle of Man in 1991 to that in 1993?
Provide a succinct answer. 3.4. What is the ratio of the Population growth (in %) of Middle income in 1991 to that in 1994?
Make the answer very short. 1.09. What is the ratio of the Population growth (in %) of Guam in 1991 to that in 1994?
Your response must be concise. 1.1. What is the ratio of the Population growth (in %) of Indonesia in 1991 to that in 1994?
Your answer should be compact. 1.04. What is the ratio of the Population growth (in %) in Isle of Man in 1991 to that in 1994?
Make the answer very short. 2.6. What is the ratio of the Population growth (in %) of Middle income in 1992 to that in 1993?
Keep it short and to the point. 1.02. What is the ratio of the Population growth (in %) of Guam in 1992 to that in 1993?
Make the answer very short. 1.03. What is the ratio of the Population growth (in %) in Indonesia in 1992 to that in 1993?
Offer a terse response. 1.02. What is the ratio of the Population growth (in %) in Isle of Man in 1992 to that in 1993?
Your answer should be compact. 1.85. What is the ratio of the Population growth (in %) in Middle income in 1992 to that in 1994?
Offer a terse response. 1.05. What is the ratio of the Population growth (in %) in Guam in 1992 to that in 1994?
Keep it short and to the point. 1.1. What is the ratio of the Population growth (in %) of Indonesia in 1992 to that in 1994?
Your answer should be very brief. 1.04. What is the ratio of the Population growth (in %) in Isle of Man in 1992 to that in 1994?
Your response must be concise. 1.41. What is the ratio of the Population growth (in %) in Middle income in 1993 to that in 1994?
Your answer should be compact. 1.02. What is the ratio of the Population growth (in %) of Guam in 1993 to that in 1994?
Give a very brief answer. 1.06. What is the ratio of the Population growth (in %) in Indonesia in 1993 to that in 1994?
Your response must be concise. 1.02. What is the ratio of the Population growth (in %) in Isle of Man in 1993 to that in 1994?
Give a very brief answer. 0.77. What is the difference between the highest and the second highest Population growth (in %) in Middle income?
Provide a succinct answer. 0.06. What is the difference between the highest and the second highest Population growth (in %) in Guam?
Offer a very short reply. 0.01. What is the difference between the highest and the second highest Population growth (in %) in Indonesia?
Offer a very short reply. 0.1. What is the difference between the highest and the second highest Population growth (in %) in Isle of Man?
Offer a terse response. 0.18. What is the difference between the highest and the lowest Population growth (in %) of Middle income?
Your response must be concise. 0.64. What is the difference between the highest and the lowest Population growth (in %) of Guam?
Your answer should be very brief. 0.76. What is the difference between the highest and the lowest Population growth (in %) of Indonesia?
Give a very brief answer. 0.31. What is the difference between the highest and the lowest Population growth (in %) in Isle of Man?
Give a very brief answer. 1.89. 